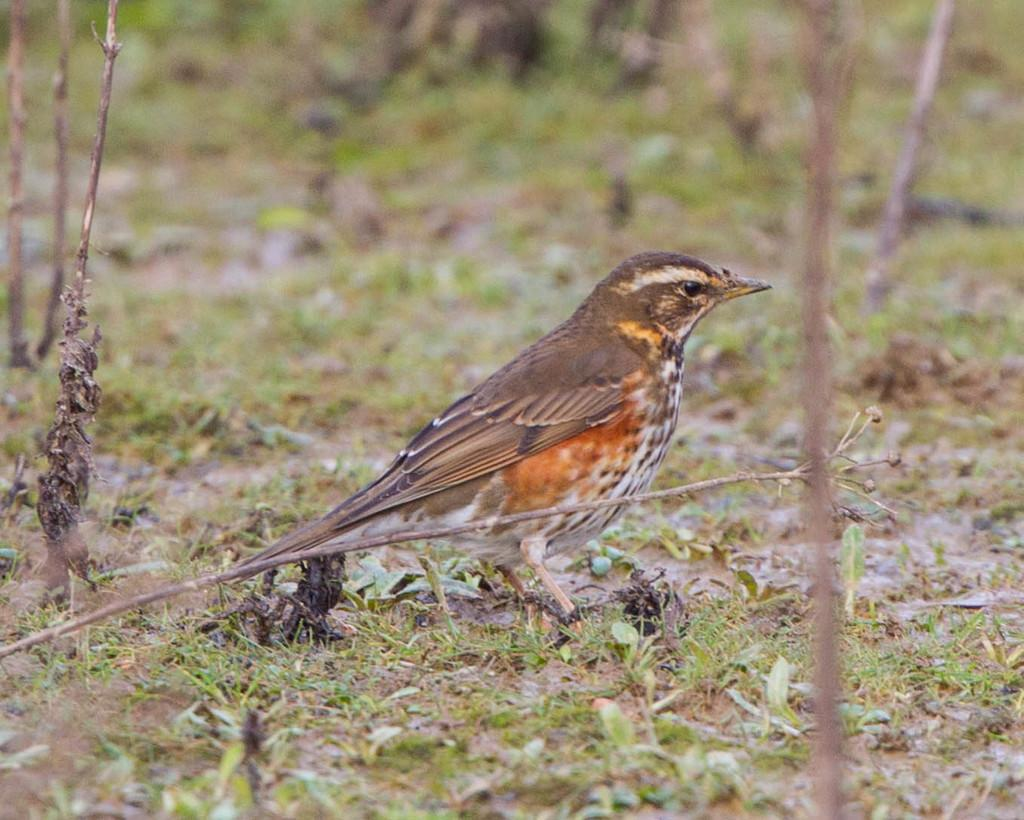What type of animal is in the image? There is a bird in the image. Where is the bird located in the image? The bird is in the center of the image. What type of environment is visible in the image? There is grassland visible in the image. What type of church can be seen in the background of the image? There is no church present in the image; it features a bird in the center of a grassland environment. 